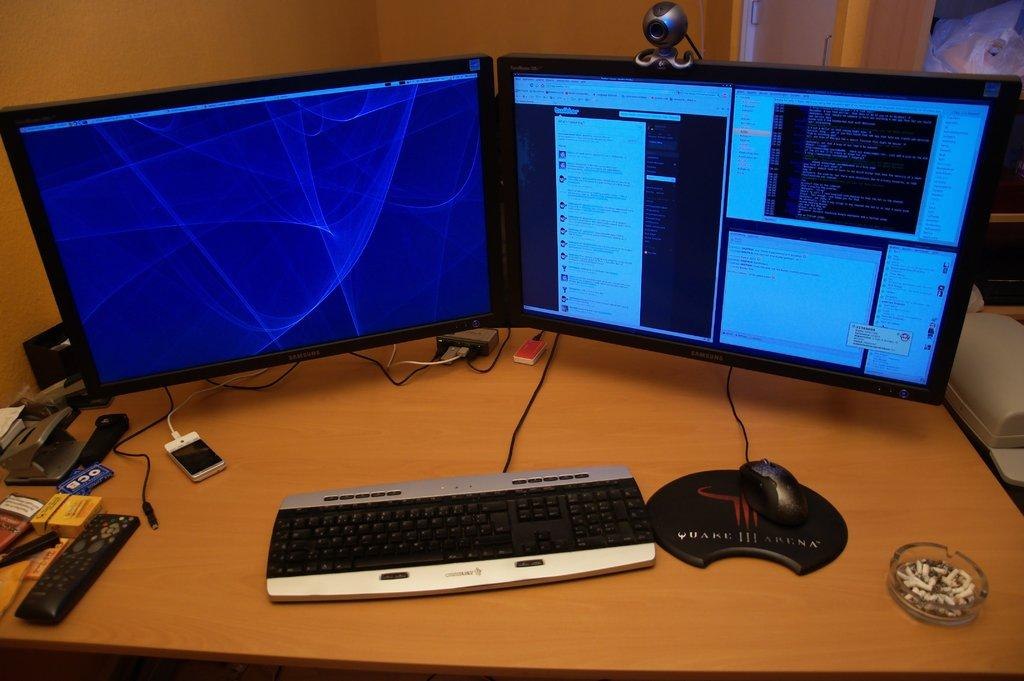<image>
Summarize the visual content of the image. A dual monitor computer set up with a silver and black keyboard and a black gaming mouse on a Quake III Arena mousepad. 